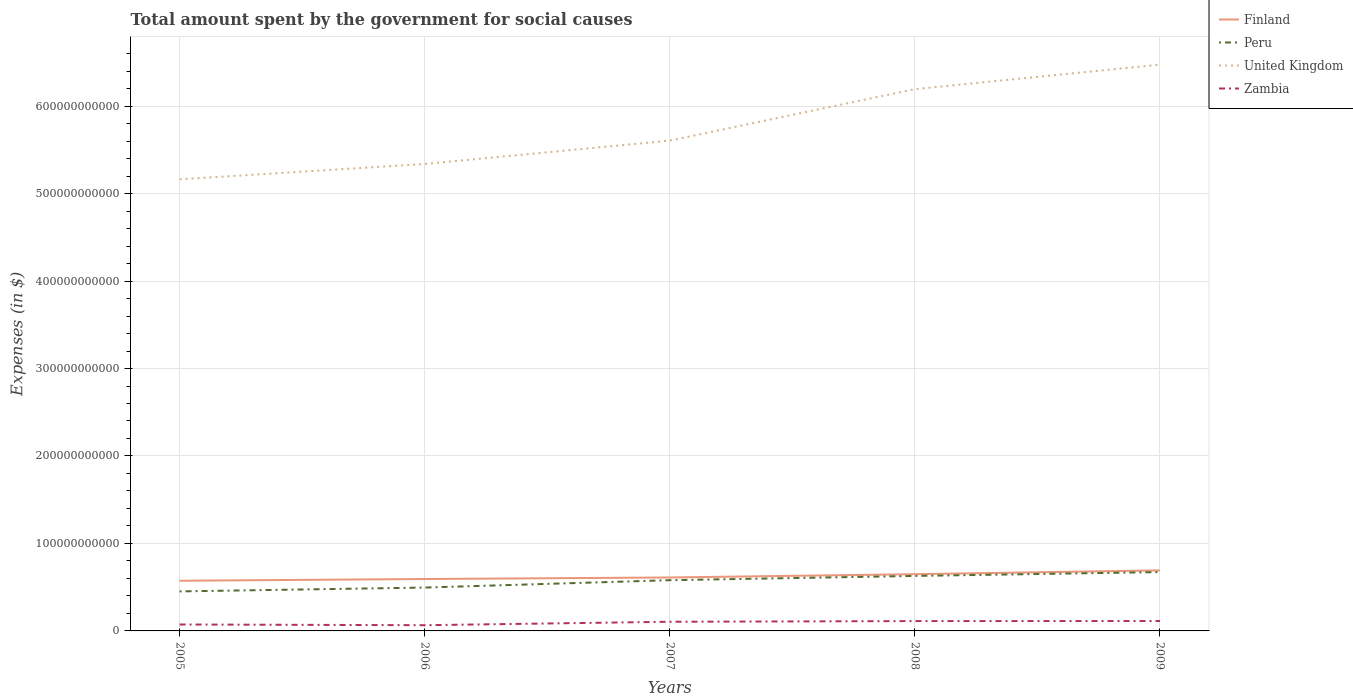How many different coloured lines are there?
Offer a terse response. 4. Is the number of lines equal to the number of legend labels?
Your answer should be very brief. Yes. Across all years, what is the maximum amount spent for social causes by the government in Zambia?
Make the answer very short. 6.54e+09. What is the total amount spent for social causes by the government in Zambia in the graph?
Provide a succinct answer. 8.04e+08. What is the difference between the highest and the second highest amount spent for social causes by the government in Peru?
Provide a short and direct response. 2.21e+1. Is the amount spent for social causes by the government in United Kingdom strictly greater than the amount spent for social causes by the government in Finland over the years?
Your answer should be very brief. No. How many years are there in the graph?
Keep it short and to the point. 5. What is the difference between two consecutive major ticks on the Y-axis?
Keep it short and to the point. 1.00e+11. Are the values on the major ticks of Y-axis written in scientific E-notation?
Your response must be concise. No. Does the graph contain any zero values?
Keep it short and to the point. No. How are the legend labels stacked?
Keep it short and to the point. Vertical. What is the title of the graph?
Your answer should be very brief. Total amount spent by the government for social causes. Does "Middle income" appear as one of the legend labels in the graph?
Your answer should be very brief. No. What is the label or title of the Y-axis?
Offer a terse response. Expenses (in $). What is the Expenses (in $) in Finland in 2005?
Make the answer very short. 5.74e+1. What is the Expenses (in $) of Peru in 2005?
Offer a terse response. 4.52e+1. What is the Expenses (in $) in United Kingdom in 2005?
Make the answer very short. 5.16e+11. What is the Expenses (in $) of Zambia in 2005?
Provide a short and direct response. 7.35e+09. What is the Expenses (in $) of Finland in 2006?
Provide a short and direct response. 5.94e+1. What is the Expenses (in $) of Peru in 2006?
Offer a very short reply. 4.96e+1. What is the Expenses (in $) of United Kingdom in 2006?
Make the answer very short. 5.34e+11. What is the Expenses (in $) in Zambia in 2006?
Provide a short and direct response. 6.54e+09. What is the Expenses (in $) of Finland in 2007?
Keep it short and to the point. 6.11e+1. What is the Expenses (in $) of Peru in 2007?
Offer a very short reply. 5.80e+1. What is the Expenses (in $) of United Kingdom in 2007?
Your response must be concise. 5.61e+11. What is the Expenses (in $) in Zambia in 2007?
Offer a very short reply. 1.05e+1. What is the Expenses (in $) in Finland in 2008?
Your response must be concise. 6.49e+1. What is the Expenses (in $) of Peru in 2008?
Keep it short and to the point. 6.29e+1. What is the Expenses (in $) of United Kingdom in 2008?
Keep it short and to the point. 6.19e+11. What is the Expenses (in $) in Zambia in 2008?
Offer a terse response. 1.13e+1. What is the Expenses (in $) in Finland in 2009?
Your answer should be compact. 6.92e+1. What is the Expenses (in $) of Peru in 2009?
Your answer should be very brief. 6.73e+1. What is the Expenses (in $) of United Kingdom in 2009?
Offer a very short reply. 6.47e+11. What is the Expenses (in $) in Zambia in 2009?
Your answer should be very brief. 1.13e+1. Across all years, what is the maximum Expenses (in $) in Finland?
Your answer should be compact. 6.92e+1. Across all years, what is the maximum Expenses (in $) in Peru?
Offer a terse response. 6.73e+1. Across all years, what is the maximum Expenses (in $) in United Kingdom?
Your answer should be compact. 6.47e+11. Across all years, what is the maximum Expenses (in $) of Zambia?
Provide a succinct answer. 1.13e+1. Across all years, what is the minimum Expenses (in $) of Finland?
Your answer should be compact. 5.74e+1. Across all years, what is the minimum Expenses (in $) of Peru?
Offer a very short reply. 4.52e+1. Across all years, what is the minimum Expenses (in $) in United Kingdom?
Ensure brevity in your answer.  5.16e+11. Across all years, what is the minimum Expenses (in $) of Zambia?
Make the answer very short. 6.54e+09. What is the total Expenses (in $) of Finland in the graph?
Offer a very short reply. 3.12e+11. What is the total Expenses (in $) in Peru in the graph?
Your answer should be compact. 2.83e+11. What is the total Expenses (in $) of United Kingdom in the graph?
Give a very brief answer. 2.88e+12. What is the total Expenses (in $) of Zambia in the graph?
Your response must be concise. 4.69e+1. What is the difference between the Expenses (in $) of Finland in 2005 and that in 2006?
Make the answer very short. -1.99e+09. What is the difference between the Expenses (in $) in Peru in 2005 and that in 2006?
Give a very brief answer. -4.39e+09. What is the difference between the Expenses (in $) in United Kingdom in 2005 and that in 2006?
Keep it short and to the point. -1.75e+1. What is the difference between the Expenses (in $) in Zambia in 2005 and that in 2006?
Offer a terse response. 8.04e+08. What is the difference between the Expenses (in $) in Finland in 2005 and that in 2007?
Provide a succinct answer. -3.73e+09. What is the difference between the Expenses (in $) in Peru in 2005 and that in 2007?
Provide a succinct answer. -1.28e+1. What is the difference between the Expenses (in $) of United Kingdom in 2005 and that in 2007?
Give a very brief answer. -4.42e+1. What is the difference between the Expenses (in $) in Zambia in 2005 and that in 2007?
Make the answer very short. -3.13e+09. What is the difference between the Expenses (in $) in Finland in 2005 and that in 2008?
Provide a succinct answer. -7.52e+09. What is the difference between the Expenses (in $) in Peru in 2005 and that in 2008?
Offer a very short reply. -1.77e+1. What is the difference between the Expenses (in $) in United Kingdom in 2005 and that in 2008?
Offer a very short reply. -1.03e+11. What is the difference between the Expenses (in $) in Zambia in 2005 and that in 2008?
Keep it short and to the point. -3.91e+09. What is the difference between the Expenses (in $) of Finland in 2005 and that in 2009?
Offer a terse response. -1.19e+1. What is the difference between the Expenses (in $) in Peru in 2005 and that in 2009?
Your answer should be very brief. -2.21e+1. What is the difference between the Expenses (in $) of United Kingdom in 2005 and that in 2009?
Your answer should be very brief. -1.31e+11. What is the difference between the Expenses (in $) of Zambia in 2005 and that in 2009?
Ensure brevity in your answer.  -3.97e+09. What is the difference between the Expenses (in $) of Finland in 2006 and that in 2007?
Your response must be concise. -1.74e+09. What is the difference between the Expenses (in $) in Peru in 2006 and that in 2007?
Your answer should be compact. -8.43e+09. What is the difference between the Expenses (in $) in United Kingdom in 2006 and that in 2007?
Provide a succinct answer. -2.67e+1. What is the difference between the Expenses (in $) of Zambia in 2006 and that in 2007?
Provide a short and direct response. -3.93e+09. What is the difference between the Expenses (in $) of Finland in 2006 and that in 2008?
Your response must be concise. -5.53e+09. What is the difference between the Expenses (in $) in Peru in 2006 and that in 2008?
Your answer should be very brief. -1.33e+1. What is the difference between the Expenses (in $) of United Kingdom in 2006 and that in 2008?
Provide a short and direct response. -8.56e+1. What is the difference between the Expenses (in $) of Zambia in 2006 and that in 2008?
Your answer should be very brief. -4.71e+09. What is the difference between the Expenses (in $) in Finland in 2006 and that in 2009?
Ensure brevity in your answer.  -9.88e+09. What is the difference between the Expenses (in $) of Peru in 2006 and that in 2009?
Offer a very short reply. -1.77e+1. What is the difference between the Expenses (in $) in United Kingdom in 2006 and that in 2009?
Offer a terse response. -1.14e+11. What is the difference between the Expenses (in $) in Zambia in 2006 and that in 2009?
Provide a short and direct response. -4.77e+09. What is the difference between the Expenses (in $) of Finland in 2007 and that in 2008?
Your answer should be very brief. -3.79e+09. What is the difference between the Expenses (in $) in Peru in 2007 and that in 2008?
Your answer should be very brief. -4.86e+09. What is the difference between the Expenses (in $) of United Kingdom in 2007 and that in 2008?
Provide a short and direct response. -5.89e+1. What is the difference between the Expenses (in $) of Zambia in 2007 and that in 2008?
Give a very brief answer. -7.76e+08. What is the difference between the Expenses (in $) in Finland in 2007 and that in 2009?
Give a very brief answer. -8.14e+09. What is the difference between the Expenses (in $) in Peru in 2007 and that in 2009?
Your answer should be very brief. -9.27e+09. What is the difference between the Expenses (in $) in United Kingdom in 2007 and that in 2009?
Give a very brief answer. -8.69e+1. What is the difference between the Expenses (in $) of Zambia in 2007 and that in 2009?
Your answer should be very brief. -8.37e+08. What is the difference between the Expenses (in $) in Finland in 2008 and that in 2009?
Make the answer very short. -4.35e+09. What is the difference between the Expenses (in $) of Peru in 2008 and that in 2009?
Keep it short and to the point. -4.41e+09. What is the difference between the Expenses (in $) in United Kingdom in 2008 and that in 2009?
Provide a short and direct response. -2.80e+1. What is the difference between the Expenses (in $) of Zambia in 2008 and that in 2009?
Keep it short and to the point. -6.12e+07. What is the difference between the Expenses (in $) of Finland in 2005 and the Expenses (in $) of Peru in 2006?
Provide a short and direct response. 7.79e+09. What is the difference between the Expenses (in $) of Finland in 2005 and the Expenses (in $) of United Kingdom in 2006?
Your answer should be compact. -4.76e+11. What is the difference between the Expenses (in $) of Finland in 2005 and the Expenses (in $) of Zambia in 2006?
Offer a terse response. 5.08e+1. What is the difference between the Expenses (in $) of Peru in 2005 and the Expenses (in $) of United Kingdom in 2006?
Make the answer very short. -4.89e+11. What is the difference between the Expenses (in $) in Peru in 2005 and the Expenses (in $) in Zambia in 2006?
Your response must be concise. 3.86e+1. What is the difference between the Expenses (in $) in United Kingdom in 2005 and the Expenses (in $) in Zambia in 2006?
Offer a very short reply. 5.10e+11. What is the difference between the Expenses (in $) of Finland in 2005 and the Expenses (in $) of Peru in 2007?
Your response must be concise. -6.41e+08. What is the difference between the Expenses (in $) in Finland in 2005 and the Expenses (in $) in United Kingdom in 2007?
Your answer should be compact. -5.03e+11. What is the difference between the Expenses (in $) in Finland in 2005 and the Expenses (in $) in Zambia in 2007?
Keep it short and to the point. 4.69e+1. What is the difference between the Expenses (in $) of Peru in 2005 and the Expenses (in $) of United Kingdom in 2007?
Ensure brevity in your answer.  -5.15e+11. What is the difference between the Expenses (in $) of Peru in 2005 and the Expenses (in $) of Zambia in 2007?
Your response must be concise. 3.47e+1. What is the difference between the Expenses (in $) of United Kingdom in 2005 and the Expenses (in $) of Zambia in 2007?
Keep it short and to the point. 5.06e+11. What is the difference between the Expenses (in $) in Finland in 2005 and the Expenses (in $) in Peru in 2008?
Make the answer very short. -5.51e+09. What is the difference between the Expenses (in $) of Finland in 2005 and the Expenses (in $) of United Kingdom in 2008?
Provide a short and direct response. -5.62e+11. What is the difference between the Expenses (in $) of Finland in 2005 and the Expenses (in $) of Zambia in 2008?
Ensure brevity in your answer.  4.61e+1. What is the difference between the Expenses (in $) of Peru in 2005 and the Expenses (in $) of United Kingdom in 2008?
Offer a terse response. -5.74e+11. What is the difference between the Expenses (in $) in Peru in 2005 and the Expenses (in $) in Zambia in 2008?
Keep it short and to the point. 3.39e+1. What is the difference between the Expenses (in $) in United Kingdom in 2005 and the Expenses (in $) in Zambia in 2008?
Your answer should be compact. 5.05e+11. What is the difference between the Expenses (in $) of Finland in 2005 and the Expenses (in $) of Peru in 2009?
Offer a terse response. -9.91e+09. What is the difference between the Expenses (in $) of Finland in 2005 and the Expenses (in $) of United Kingdom in 2009?
Your response must be concise. -5.90e+11. What is the difference between the Expenses (in $) of Finland in 2005 and the Expenses (in $) of Zambia in 2009?
Your answer should be very brief. 4.60e+1. What is the difference between the Expenses (in $) in Peru in 2005 and the Expenses (in $) in United Kingdom in 2009?
Keep it short and to the point. -6.02e+11. What is the difference between the Expenses (in $) of Peru in 2005 and the Expenses (in $) of Zambia in 2009?
Make the answer very short. 3.39e+1. What is the difference between the Expenses (in $) of United Kingdom in 2005 and the Expenses (in $) of Zambia in 2009?
Offer a very short reply. 5.05e+11. What is the difference between the Expenses (in $) in Finland in 2006 and the Expenses (in $) in Peru in 2007?
Provide a short and direct response. 1.35e+09. What is the difference between the Expenses (in $) of Finland in 2006 and the Expenses (in $) of United Kingdom in 2007?
Keep it short and to the point. -5.01e+11. What is the difference between the Expenses (in $) in Finland in 2006 and the Expenses (in $) in Zambia in 2007?
Keep it short and to the point. 4.89e+1. What is the difference between the Expenses (in $) of Peru in 2006 and the Expenses (in $) of United Kingdom in 2007?
Give a very brief answer. -5.11e+11. What is the difference between the Expenses (in $) in Peru in 2006 and the Expenses (in $) in Zambia in 2007?
Your answer should be very brief. 3.91e+1. What is the difference between the Expenses (in $) in United Kingdom in 2006 and the Expenses (in $) in Zambia in 2007?
Your answer should be very brief. 5.23e+11. What is the difference between the Expenses (in $) in Finland in 2006 and the Expenses (in $) in Peru in 2008?
Offer a very short reply. -3.52e+09. What is the difference between the Expenses (in $) of Finland in 2006 and the Expenses (in $) of United Kingdom in 2008?
Offer a terse response. -5.60e+11. What is the difference between the Expenses (in $) in Finland in 2006 and the Expenses (in $) in Zambia in 2008?
Provide a succinct answer. 4.81e+1. What is the difference between the Expenses (in $) in Peru in 2006 and the Expenses (in $) in United Kingdom in 2008?
Offer a very short reply. -5.70e+11. What is the difference between the Expenses (in $) in Peru in 2006 and the Expenses (in $) in Zambia in 2008?
Your answer should be compact. 3.83e+1. What is the difference between the Expenses (in $) in United Kingdom in 2006 and the Expenses (in $) in Zambia in 2008?
Offer a very short reply. 5.23e+11. What is the difference between the Expenses (in $) in Finland in 2006 and the Expenses (in $) in Peru in 2009?
Ensure brevity in your answer.  -7.92e+09. What is the difference between the Expenses (in $) in Finland in 2006 and the Expenses (in $) in United Kingdom in 2009?
Keep it short and to the point. -5.88e+11. What is the difference between the Expenses (in $) of Finland in 2006 and the Expenses (in $) of Zambia in 2009?
Give a very brief answer. 4.80e+1. What is the difference between the Expenses (in $) of Peru in 2006 and the Expenses (in $) of United Kingdom in 2009?
Provide a succinct answer. -5.98e+11. What is the difference between the Expenses (in $) of Peru in 2006 and the Expenses (in $) of Zambia in 2009?
Your response must be concise. 3.83e+1. What is the difference between the Expenses (in $) in United Kingdom in 2006 and the Expenses (in $) in Zambia in 2009?
Offer a very short reply. 5.23e+11. What is the difference between the Expenses (in $) of Finland in 2007 and the Expenses (in $) of Peru in 2008?
Your response must be concise. -1.78e+09. What is the difference between the Expenses (in $) in Finland in 2007 and the Expenses (in $) in United Kingdom in 2008?
Ensure brevity in your answer.  -5.58e+11. What is the difference between the Expenses (in $) in Finland in 2007 and the Expenses (in $) in Zambia in 2008?
Make the answer very short. 4.98e+1. What is the difference between the Expenses (in $) of Peru in 2007 and the Expenses (in $) of United Kingdom in 2008?
Provide a short and direct response. -5.61e+11. What is the difference between the Expenses (in $) of Peru in 2007 and the Expenses (in $) of Zambia in 2008?
Your response must be concise. 4.68e+1. What is the difference between the Expenses (in $) in United Kingdom in 2007 and the Expenses (in $) in Zambia in 2008?
Offer a terse response. 5.49e+11. What is the difference between the Expenses (in $) of Finland in 2007 and the Expenses (in $) of Peru in 2009?
Provide a short and direct response. -6.18e+09. What is the difference between the Expenses (in $) of Finland in 2007 and the Expenses (in $) of United Kingdom in 2009?
Keep it short and to the point. -5.86e+11. What is the difference between the Expenses (in $) in Finland in 2007 and the Expenses (in $) in Zambia in 2009?
Provide a succinct answer. 4.98e+1. What is the difference between the Expenses (in $) in Peru in 2007 and the Expenses (in $) in United Kingdom in 2009?
Keep it short and to the point. -5.89e+11. What is the difference between the Expenses (in $) of Peru in 2007 and the Expenses (in $) of Zambia in 2009?
Keep it short and to the point. 4.67e+1. What is the difference between the Expenses (in $) in United Kingdom in 2007 and the Expenses (in $) in Zambia in 2009?
Your answer should be compact. 5.49e+11. What is the difference between the Expenses (in $) in Finland in 2008 and the Expenses (in $) in Peru in 2009?
Keep it short and to the point. -2.39e+09. What is the difference between the Expenses (in $) of Finland in 2008 and the Expenses (in $) of United Kingdom in 2009?
Make the answer very short. -5.83e+11. What is the difference between the Expenses (in $) of Finland in 2008 and the Expenses (in $) of Zambia in 2009?
Your response must be concise. 5.36e+1. What is the difference between the Expenses (in $) of Peru in 2008 and the Expenses (in $) of United Kingdom in 2009?
Keep it short and to the point. -5.85e+11. What is the difference between the Expenses (in $) in Peru in 2008 and the Expenses (in $) in Zambia in 2009?
Your answer should be compact. 5.16e+1. What is the difference between the Expenses (in $) in United Kingdom in 2008 and the Expenses (in $) in Zambia in 2009?
Ensure brevity in your answer.  6.08e+11. What is the average Expenses (in $) of Finland per year?
Keep it short and to the point. 6.24e+1. What is the average Expenses (in $) of Peru per year?
Your answer should be very brief. 5.66e+1. What is the average Expenses (in $) of United Kingdom per year?
Your answer should be very brief. 5.76e+11. What is the average Expenses (in $) in Zambia per year?
Your answer should be very brief. 9.39e+09. In the year 2005, what is the difference between the Expenses (in $) of Finland and Expenses (in $) of Peru?
Make the answer very short. 1.22e+1. In the year 2005, what is the difference between the Expenses (in $) of Finland and Expenses (in $) of United Kingdom?
Keep it short and to the point. -4.59e+11. In the year 2005, what is the difference between the Expenses (in $) of Finland and Expenses (in $) of Zambia?
Provide a short and direct response. 5.00e+1. In the year 2005, what is the difference between the Expenses (in $) in Peru and Expenses (in $) in United Kingdom?
Provide a succinct answer. -4.71e+11. In the year 2005, what is the difference between the Expenses (in $) of Peru and Expenses (in $) of Zambia?
Your answer should be compact. 3.78e+1. In the year 2005, what is the difference between the Expenses (in $) in United Kingdom and Expenses (in $) in Zambia?
Your answer should be compact. 5.09e+11. In the year 2006, what is the difference between the Expenses (in $) of Finland and Expenses (in $) of Peru?
Offer a very short reply. 9.78e+09. In the year 2006, what is the difference between the Expenses (in $) in Finland and Expenses (in $) in United Kingdom?
Your response must be concise. -4.74e+11. In the year 2006, what is the difference between the Expenses (in $) in Finland and Expenses (in $) in Zambia?
Provide a succinct answer. 5.28e+1. In the year 2006, what is the difference between the Expenses (in $) in Peru and Expenses (in $) in United Kingdom?
Your answer should be compact. -4.84e+11. In the year 2006, what is the difference between the Expenses (in $) in Peru and Expenses (in $) in Zambia?
Your response must be concise. 4.30e+1. In the year 2006, what is the difference between the Expenses (in $) in United Kingdom and Expenses (in $) in Zambia?
Ensure brevity in your answer.  5.27e+11. In the year 2007, what is the difference between the Expenses (in $) in Finland and Expenses (in $) in Peru?
Make the answer very short. 3.09e+09. In the year 2007, what is the difference between the Expenses (in $) in Finland and Expenses (in $) in United Kingdom?
Provide a succinct answer. -4.99e+11. In the year 2007, what is the difference between the Expenses (in $) in Finland and Expenses (in $) in Zambia?
Your answer should be very brief. 5.06e+1. In the year 2007, what is the difference between the Expenses (in $) in Peru and Expenses (in $) in United Kingdom?
Offer a very short reply. -5.03e+11. In the year 2007, what is the difference between the Expenses (in $) in Peru and Expenses (in $) in Zambia?
Make the answer very short. 4.75e+1. In the year 2007, what is the difference between the Expenses (in $) of United Kingdom and Expenses (in $) of Zambia?
Make the answer very short. 5.50e+11. In the year 2008, what is the difference between the Expenses (in $) in Finland and Expenses (in $) in Peru?
Keep it short and to the point. 2.01e+09. In the year 2008, what is the difference between the Expenses (in $) in Finland and Expenses (in $) in United Kingdom?
Give a very brief answer. -5.55e+11. In the year 2008, what is the difference between the Expenses (in $) of Finland and Expenses (in $) of Zambia?
Ensure brevity in your answer.  5.36e+1. In the year 2008, what is the difference between the Expenses (in $) of Peru and Expenses (in $) of United Kingdom?
Ensure brevity in your answer.  -5.57e+11. In the year 2008, what is the difference between the Expenses (in $) in Peru and Expenses (in $) in Zambia?
Your response must be concise. 5.16e+1. In the year 2008, what is the difference between the Expenses (in $) of United Kingdom and Expenses (in $) of Zambia?
Your answer should be compact. 6.08e+11. In the year 2009, what is the difference between the Expenses (in $) in Finland and Expenses (in $) in Peru?
Ensure brevity in your answer.  1.96e+09. In the year 2009, what is the difference between the Expenses (in $) in Finland and Expenses (in $) in United Kingdom?
Keep it short and to the point. -5.78e+11. In the year 2009, what is the difference between the Expenses (in $) in Finland and Expenses (in $) in Zambia?
Keep it short and to the point. 5.79e+1. In the year 2009, what is the difference between the Expenses (in $) in Peru and Expenses (in $) in United Kingdom?
Your answer should be very brief. -5.80e+11. In the year 2009, what is the difference between the Expenses (in $) of Peru and Expenses (in $) of Zambia?
Your answer should be very brief. 5.60e+1. In the year 2009, what is the difference between the Expenses (in $) of United Kingdom and Expenses (in $) of Zambia?
Offer a terse response. 6.36e+11. What is the ratio of the Expenses (in $) in Finland in 2005 to that in 2006?
Your answer should be very brief. 0.97. What is the ratio of the Expenses (in $) of Peru in 2005 to that in 2006?
Your answer should be very brief. 0.91. What is the ratio of the Expenses (in $) of United Kingdom in 2005 to that in 2006?
Your answer should be very brief. 0.97. What is the ratio of the Expenses (in $) in Zambia in 2005 to that in 2006?
Offer a very short reply. 1.12. What is the ratio of the Expenses (in $) in Finland in 2005 to that in 2007?
Provide a succinct answer. 0.94. What is the ratio of the Expenses (in $) in Peru in 2005 to that in 2007?
Your answer should be compact. 0.78. What is the ratio of the Expenses (in $) in United Kingdom in 2005 to that in 2007?
Offer a very short reply. 0.92. What is the ratio of the Expenses (in $) in Zambia in 2005 to that in 2007?
Your answer should be very brief. 0.7. What is the ratio of the Expenses (in $) in Finland in 2005 to that in 2008?
Give a very brief answer. 0.88. What is the ratio of the Expenses (in $) in Peru in 2005 to that in 2008?
Your response must be concise. 0.72. What is the ratio of the Expenses (in $) in United Kingdom in 2005 to that in 2008?
Offer a very short reply. 0.83. What is the ratio of the Expenses (in $) of Zambia in 2005 to that in 2008?
Your response must be concise. 0.65. What is the ratio of the Expenses (in $) of Finland in 2005 to that in 2009?
Ensure brevity in your answer.  0.83. What is the ratio of the Expenses (in $) in Peru in 2005 to that in 2009?
Give a very brief answer. 0.67. What is the ratio of the Expenses (in $) of United Kingdom in 2005 to that in 2009?
Your answer should be compact. 0.8. What is the ratio of the Expenses (in $) in Zambia in 2005 to that in 2009?
Keep it short and to the point. 0.65. What is the ratio of the Expenses (in $) in Finland in 2006 to that in 2007?
Your answer should be very brief. 0.97. What is the ratio of the Expenses (in $) in Peru in 2006 to that in 2007?
Provide a short and direct response. 0.85. What is the ratio of the Expenses (in $) in United Kingdom in 2006 to that in 2007?
Your response must be concise. 0.95. What is the ratio of the Expenses (in $) of Zambia in 2006 to that in 2007?
Provide a short and direct response. 0.62. What is the ratio of the Expenses (in $) in Finland in 2006 to that in 2008?
Provide a succinct answer. 0.91. What is the ratio of the Expenses (in $) of Peru in 2006 to that in 2008?
Offer a terse response. 0.79. What is the ratio of the Expenses (in $) in United Kingdom in 2006 to that in 2008?
Keep it short and to the point. 0.86. What is the ratio of the Expenses (in $) in Zambia in 2006 to that in 2008?
Ensure brevity in your answer.  0.58. What is the ratio of the Expenses (in $) in Finland in 2006 to that in 2009?
Your response must be concise. 0.86. What is the ratio of the Expenses (in $) of Peru in 2006 to that in 2009?
Provide a succinct answer. 0.74. What is the ratio of the Expenses (in $) in United Kingdom in 2006 to that in 2009?
Give a very brief answer. 0.82. What is the ratio of the Expenses (in $) of Zambia in 2006 to that in 2009?
Provide a succinct answer. 0.58. What is the ratio of the Expenses (in $) of Finland in 2007 to that in 2008?
Your response must be concise. 0.94. What is the ratio of the Expenses (in $) of Peru in 2007 to that in 2008?
Provide a succinct answer. 0.92. What is the ratio of the Expenses (in $) in United Kingdom in 2007 to that in 2008?
Provide a short and direct response. 0.91. What is the ratio of the Expenses (in $) in Zambia in 2007 to that in 2008?
Provide a succinct answer. 0.93. What is the ratio of the Expenses (in $) in Finland in 2007 to that in 2009?
Give a very brief answer. 0.88. What is the ratio of the Expenses (in $) in Peru in 2007 to that in 2009?
Your answer should be very brief. 0.86. What is the ratio of the Expenses (in $) in United Kingdom in 2007 to that in 2009?
Offer a very short reply. 0.87. What is the ratio of the Expenses (in $) in Zambia in 2007 to that in 2009?
Give a very brief answer. 0.93. What is the ratio of the Expenses (in $) of Finland in 2008 to that in 2009?
Ensure brevity in your answer.  0.94. What is the ratio of the Expenses (in $) in Peru in 2008 to that in 2009?
Offer a very short reply. 0.93. What is the ratio of the Expenses (in $) in United Kingdom in 2008 to that in 2009?
Your response must be concise. 0.96. What is the difference between the highest and the second highest Expenses (in $) in Finland?
Your answer should be compact. 4.35e+09. What is the difference between the highest and the second highest Expenses (in $) of Peru?
Offer a very short reply. 4.41e+09. What is the difference between the highest and the second highest Expenses (in $) of United Kingdom?
Provide a short and direct response. 2.80e+1. What is the difference between the highest and the second highest Expenses (in $) in Zambia?
Your answer should be very brief. 6.12e+07. What is the difference between the highest and the lowest Expenses (in $) of Finland?
Your answer should be compact. 1.19e+1. What is the difference between the highest and the lowest Expenses (in $) in Peru?
Ensure brevity in your answer.  2.21e+1. What is the difference between the highest and the lowest Expenses (in $) in United Kingdom?
Make the answer very short. 1.31e+11. What is the difference between the highest and the lowest Expenses (in $) in Zambia?
Offer a terse response. 4.77e+09. 